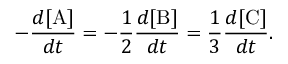<formula> <loc_0><loc_0><loc_500><loc_500>- { \frac { d [ A ] } { d t } } = - { \frac { 1 } { 2 } } { \frac { d [ B ] } { d t } } = { \frac { 1 } { 3 } } { \frac { d [ C ] } { d t } } .</formula> 